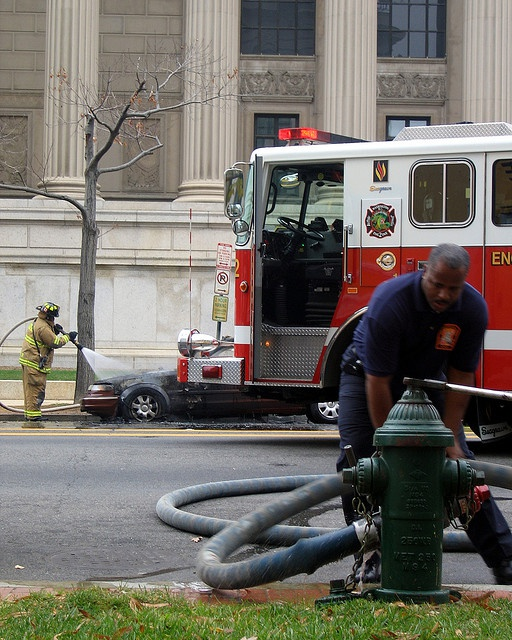Describe the objects in this image and their specific colors. I can see truck in gray, black, lightgray, and maroon tones, people in gray, black, navy, and maroon tones, fire hydrant in gray, black, purple, and darkgray tones, car in gray, black, darkgray, and maroon tones, and people in gray, olive, black, and tan tones in this image. 